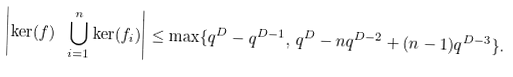Convert formula to latex. <formula><loc_0><loc_0><loc_500><loc_500>\left | \ker ( f ) \ \bigcup _ { i = 1 } ^ { n } \ker ( f _ { i } ) \right | \leq \max \{ q ^ { D } - q ^ { D - 1 } , \, q ^ { D } - n q ^ { D - 2 } + ( n - 1 ) q ^ { D - 3 } \} .</formula> 